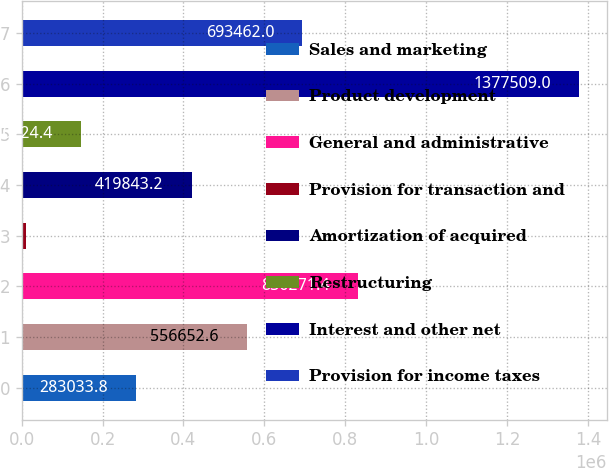<chart> <loc_0><loc_0><loc_500><loc_500><bar_chart><fcel>Sales and marketing<fcel>Product development<fcel>General and administrative<fcel>Provision for transaction and<fcel>Amortization of acquired<fcel>Restructuring<fcel>Interest and other net<fcel>Provision for income taxes<nl><fcel>283034<fcel>556653<fcel>830271<fcel>9415<fcel>419843<fcel>146224<fcel>1.37751e+06<fcel>693462<nl></chart> 